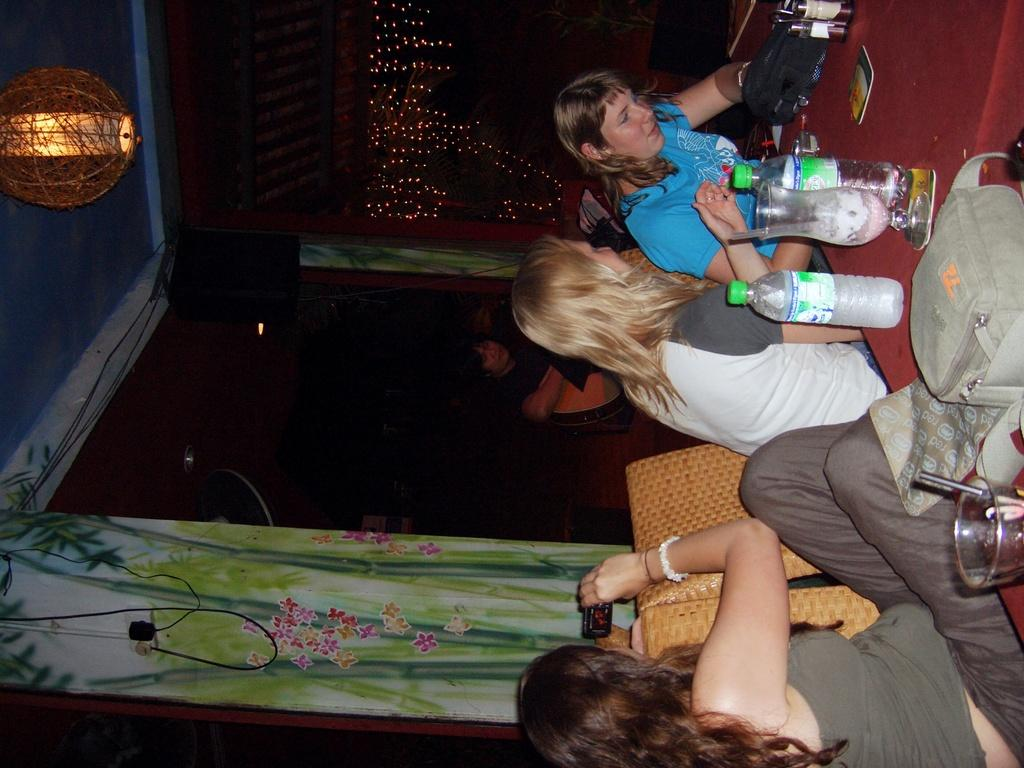What is the position of the girls in the image? The girls are sitting on the right side of the image. What objects are on the left side of the image? There are speakers and curtains on the left side of the image. What might be used for amplifying sound in the image? Speakers are present in the image for amplifying sound. What type of window treatment is visible in the image? Curtains are present in the image as window treatment. What type of authority figure can be seen in the image? There is no authority figure present in the image. What type of boats are visible in the image? There are no boats present in the image. 